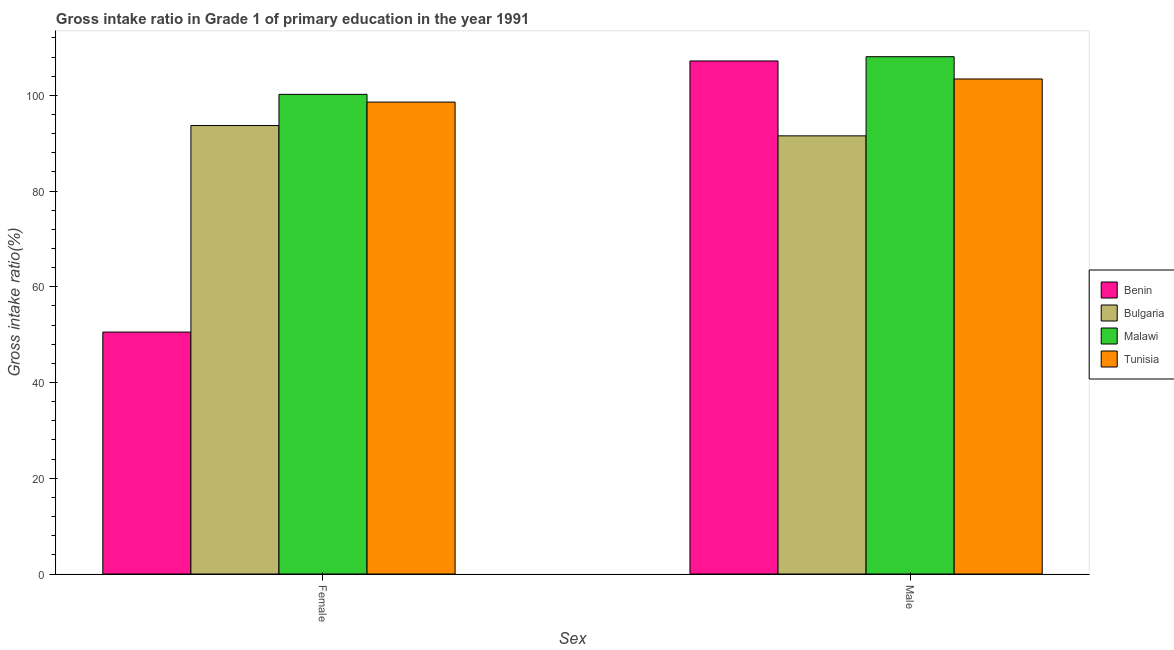Are the number of bars per tick equal to the number of legend labels?
Provide a succinct answer. Yes. Are the number of bars on each tick of the X-axis equal?
Keep it short and to the point. Yes. What is the label of the 2nd group of bars from the left?
Your answer should be compact. Male. What is the gross intake ratio(female) in Malawi?
Your response must be concise. 100.2. Across all countries, what is the maximum gross intake ratio(male)?
Make the answer very short. 108.07. Across all countries, what is the minimum gross intake ratio(male)?
Your answer should be very brief. 91.53. In which country was the gross intake ratio(female) maximum?
Offer a very short reply. Malawi. What is the total gross intake ratio(male) in the graph?
Your answer should be compact. 410.2. What is the difference between the gross intake ratio(female) in Bulgaria and that in Malawi?
Offer a terse response. -6.52. What is the difference between the gross intake ratio(male) in Malawi and the gross intake ratio(female) in Bulgaria?
Your answer should be very brief. 14.38. What is the average gross intake ratio(female) per country?
Your answer should be very brief. 85.76. What is the difference between the gross intake ratio(female) and gross intake ratio(male) in Tunisia?
Make the answer very short. -4.83. In how many countries, is the gross intake ratio(male) greater than 52 %?
Your response must be concise. 4. What is the ratio of the gross intake ratio(male) in Benin to that in Bulgaria?
Make the answer very short. 1.17. Is the gross intake ratio(male) in Malawi less than that in Tunisia?
Offer a terse response. No. In how many countries, is the gross intake ratio(male) greater than the average gross intake ratio(male) taken over all countries?
Give a very brief answer. 3. What does the 4th bar from the left in Female represents?
Keep it short and to the point. Tunisia. What does the 1st bar from the right in Male represents?
Provide a short and direct response. Tunisia. Are all the bars in the graph horizontal?
Offer a very short reply. No. What is the difference between two consecutive major ticks on the Y-axis?
Provide a short and direct response. 20. Where does the legend appear in the graph?
Your answer should be compact. Center right. What is the title of the graph?
Ensure brevity in your answer.  Gross intake ratio in Grade 1 of primary education in the year 1991. What is the label or title of the X-axis?
Ensure brevity in your answer.  Sex. What is the label or title of the Y-axis?
Ensure brevity in your answer.  Gross intake ratio(%). What is the Gross intake ratio(%) of Benin in Female?
Your answer should be compact. 50.54. What is the Gross intake ratio(%) in Bulgaria in Female?
Provide a short and direct response. 93.69. What is the Gross intake ratio(%) in Malawi in Female?
Your response must be concise. 100.2. What is the Gross intake ratio(%) in Tunisia in Female?
Keep it short and to the point. 98.59. What is the Gross intake ratio(%) in Benin in Male?
Offer a very short reply. 107.18. What is the Gross intake ratio(%) of Bulgaria in Male?
Provide a succinct answer. 91.53. What is the Gross intake ratio(%) in Malawi in Male?
Your answer should be compact. 108.07. What is the Gross intake ratio(%) in Tunisia in Male?
Your answer should be compact. 103.41. Across all Sex, what is the maximum Gross intake ratio(%) of Benin?
Ensure brevity in your answer.  107.18. Across all Sex, what is the maximum Gross intake ratio(%) of Bulgaria?
Your answer should be very brief. 93.69. Across all Sex, what is the maximum Gross intake ratio(%) in Malawi?
Provide a short and direct response. 108.07. Across all Sex, what is the maximum Gross intake ratio(%) of Tunisia?
Make the answer very short. 103.41. Across all Sex, what is the minimum Gross intake ratio(%) in Benin?
Keep it short and to the point. 50.54. Across all Sex, what is the minimum Gross intake ratio(%) in Bulgaria?
Keep it short and to the point. 91.53. Across all Sex, what is the minimum Gross intake ratio(%) in Malawi?
Offer a terse response. 100.2. Across all Sex, what is the minimum Gross intake ratio(%) of Tunisia?
Your answer should be very brief. 98.59. What is the total Gross intake ratio(%) of Benin in the graph?
Your answer should be compact. 157.72. What is the total Gross intake ratio(%) of Bulgaria in the graph?
Offer a very short reply. 185.22. What is the total Gross intake ratio(%) in Malawi in the graph?
Your response must be concise. 208.28. What is the total Gross intake ratio(%) of Tunisia in the graph?
Give a very brief answer. 202. What is the difference between the Gross intake ratio(%) in Benin in Female and that in Male?
Your answer should be very brief. -56.64. What is the difference between the Gross intake ratio(%) of Bulgaria in Female and that in Male?
Your answer should be very brief. 2.15. What is the difference between the Gross intake ratio(%) in Malawi in Female and that in Male?
Ensure brevity in your answer.  -7.87. What is the difference between the Gross intake ratio(%) in Tunisia in Female and that in Male?
Your response must be concise. -4.83. What is the difference between the Gross intake ratio(%) of Benin in Female and the Gross intake ratio(%) of Bulgaria in Male?
Give a very brief answer. -40.99. What is the difference between the Gross intake ratio(%) of Benin in Female and the Gross intake ratio(%) of Malawi in Male?
Your answer should be very brief. -57.53. What is the difference between the Gross intake ratio(%) of Benin in Female and the Gross intake ratio(%) of Tunisia in Male?
Your answer should be very brief. -52.87. What is the difference between the Gross intake ratio(%) in Bulgaria in Female and the Gross intake ratio(%) in Malawi in Male?
Your answer should be compact. -14.38. What is the difference between the Gross intake ratio(%) in Bulgaria in Female and the Gross intake ratio(%) in Tunisia in Male?
Provide a short and direct response. -9.73. What is the difference between the Gross intake ratio(%) in Malawi in Female and the Gross intake ratio(%) in Tunisia in Male?
Your answer should be compact. -3.21. What is the average Gross intake ratio(%) in Benin per Sex?
Your answer should be compact. 78.86. What is the average Gross intake ratio(%) of Bulgaria per Sex?
Your answer should be very brief. 92.61. What is the average Gross intake ratio(%) of Malawi per Sex?
Offer a terse response. 104.14. What is the average Gross intake ratio(%) in Tunisia per Sex?
Provide a short and direct response. 101. What is the difference between the Gross intake ratio(%) in Benin and Gross intake ratio(%) in Bulgaria in Female?
Your answer should be very brief. -43.14. What is the difference between the Gross intake ratio(%) of Benin and Gross intake ratio(%) of Malawi in Female?
Your response must be concise. -49.66. What is the difference between the Gross intake ratio(%) of Benin and Gross intake ratio(%) of Tunisia in Female?
Your answer should be compact. -48.04. What is the difference between the Gross intake ratio(%) of Bulgaria and Gross intake ratio(%) of Malawi in Female?
Offer a terse response. -6.52. What is the difference between the Gross intake ratio(%) in Bulgaria and Gross intake ratio(%) in Tunisia in Female?
Your answer should be very brief. -4.9. What is the difference between the Gross intake ratio(%) of Malawi and Gross intake ratio(%) of Tunisia in Female?
Your answer should be compact. 1.62. What is the difference between the Gross intake ratio(%) in Benin and Gross intake ratio(%) in Bulgaria in Male?
Keep it short and to the point. 15.65. What is the difference between the Gross intake ratio(%) of Benin and Gross intake ratio(%) of Malawi in Male?
Give a very brief answer. -0.89. What is the difference between the Gross intake ratio(%) of Benin and Gross intake ratio(%) of Tunisia in Male?
Offer a terse response. 3.77. What is the difference between the Gross intake ratio(%) in Bulgaria and Gross intake ratio(%) in Malawi in Male?
Provide a succinct answer. -16.54. What is the difference between the Gross intake ratio(%) of Bulgaria and Gross intake ratio(%) of Tunisia in Male?
Make the answer very short. -11.88. What is the difference between the Gross intake ratio(%) in Malawi and Gross intake ratio(%) in Tunisia in Male?
Provide a succinct answer. 4.66. What is the ratio of the Gross intake ratio(%) in Benin in Female to that in Male?
Give a very brief answer. 0.47. What is the ratio of the Gross intake ratio(%) in Bulgaria in Female to that in Male?
Give a very brief answer. 1.02. What is the ratio of the Gross intake ratio(%) in Malawi in Female to that in Male?
Your answer should be very brief. 0.93. What is the ratio of the Gross intake ratio(%) of Tunisia in Female to that in Male?
Your response must be concise. 0.95. What is the difference between the highest and the second highest Gross intake ratio(%) of Benin?
Provide a succinct answer. 56.64. What is the difference between the highest and the second highest Gross intake ratio(%) of Bulgaria?
Make the answer very short. 2.15. What is the difference between the highest and the second highest Gross intake ratio(%) of Malawi?
Your answer should be very brief. 7.87. What is the difference between the highest and the second highest Gross intake ratio(%) in Tunisia?
Offer a very short reply. 4.83. What is the difference between the highest and the lowest Gross intake ratio(%) in Benin?
Offer a very short reply. 56.64. What is the difference between the highest and the lowest Gross intake ratio(%) in Bulgaria?
Provide a short and direct response. 2.15. What is the difference between the highest and the lowest Gross intake ratio(%) in Malawi?
Make the answer very short. 7.87. What is the difference between the highest and the lowest Gross intake ratio(%) of Tunisia?
Offer a terse response. 4.83. 